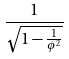Convert formula to latex. <formula><loc_0><loc_0><loc_500><loc_500>\frac { 1 } { \sqrt { 1 - \frac { 1 } { \phi ^ { 2 } } } }</formula> 